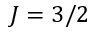<formula> <loc_0><loc_0><loc_500><loc_500>J = 3 / 2</formula> 